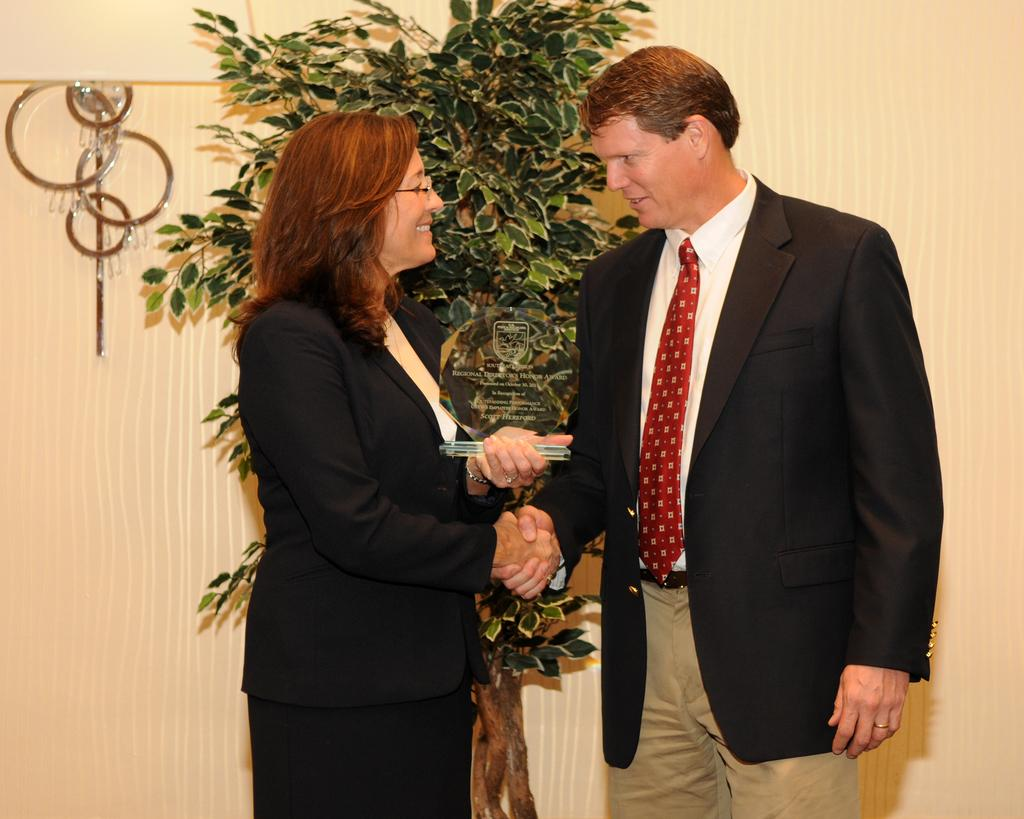Who is present in the image? There is a man and a lady in the image. What are the man and lady doing in the image? The man and lady are shaking hands in the image. What is the lady holding in her hand? There is an object in the lady's hand in the image. What can be seen in the background of the image? There is a plant visible in the background of the image. What is on the wall in the image? There is an object on the wall in the image. What is the purpose of the argument between the man and lady in the image? There is no argument between the man and lady in the image; they are shaking hands. What type of meeting is taking place in the image? There is no meeting depicted in the image; it only shows the man and lady shaking hands. 